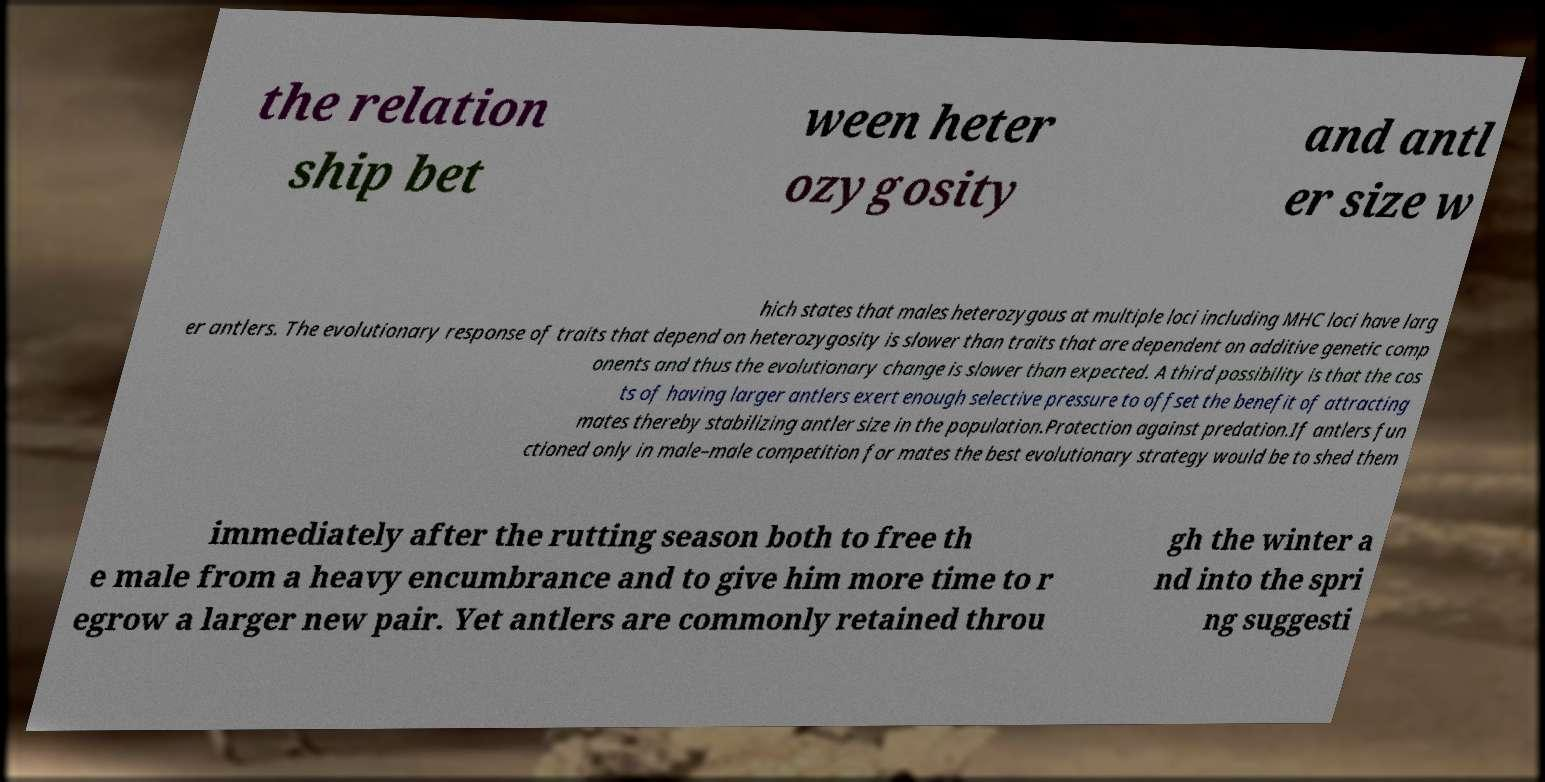Can you accurately transcribe the text from the provided image for me? the relation ship bet ween heter ozygosity and antl er size w hich states that males heterozygous at multiple loci including MHC loci have larg er antlers. The evolutionary response of traits that depend on heterozygosity is slower than traits that are dependent on additive genetic comp onents and thus the evolutionary change is slower than expected. A third possibility is that the cos ts of having larger antlers exert enough selective pressure to offset the benefit of attracting mates thereby stabilizing antler size in the population.Protection against predation.If antlers fun ctioned only in male–male competition for mates the best evolutionary strategy would be to shed them immediately after the rutting season both to free th e male from a heavy encumbrance and to give him more time to r egrow a larger new pair. Yet antlers are commonly retained throu gh the winter a nd into the spri ng suggesti 